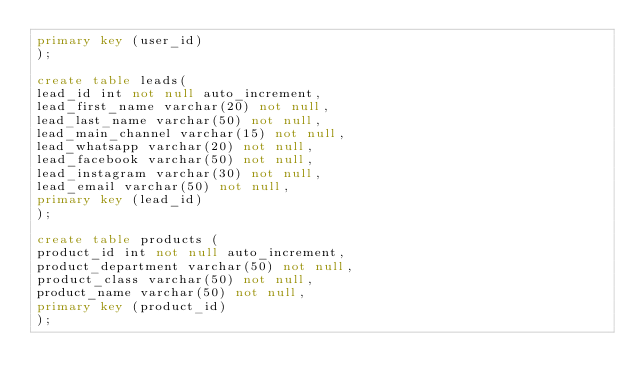Convert code to text. <code><loc_0><loc_0><loc_500><loc_500><_SQL_>primary key (user_id)
);

create table leads(
lead_id int not null auto_increment,
lead_first_name varchar(20) not null,
lead_last_name varchar(50) not null,
lead_main_channel varchar(15) not null,
lead_whatsapp varchar(20) not null,
lead_facebook varchar(50) not null,
lead_instagram varchar(30) not null,
lead_email varchar(50) not null,
primary key (lead_id)
);

create table products (
product_id int not null auto_increment,
product_department varchar(50) not null,
product_class varchar(50) not null,
product_name varchar(50) not null,
primary key (product_id)
); </code> 